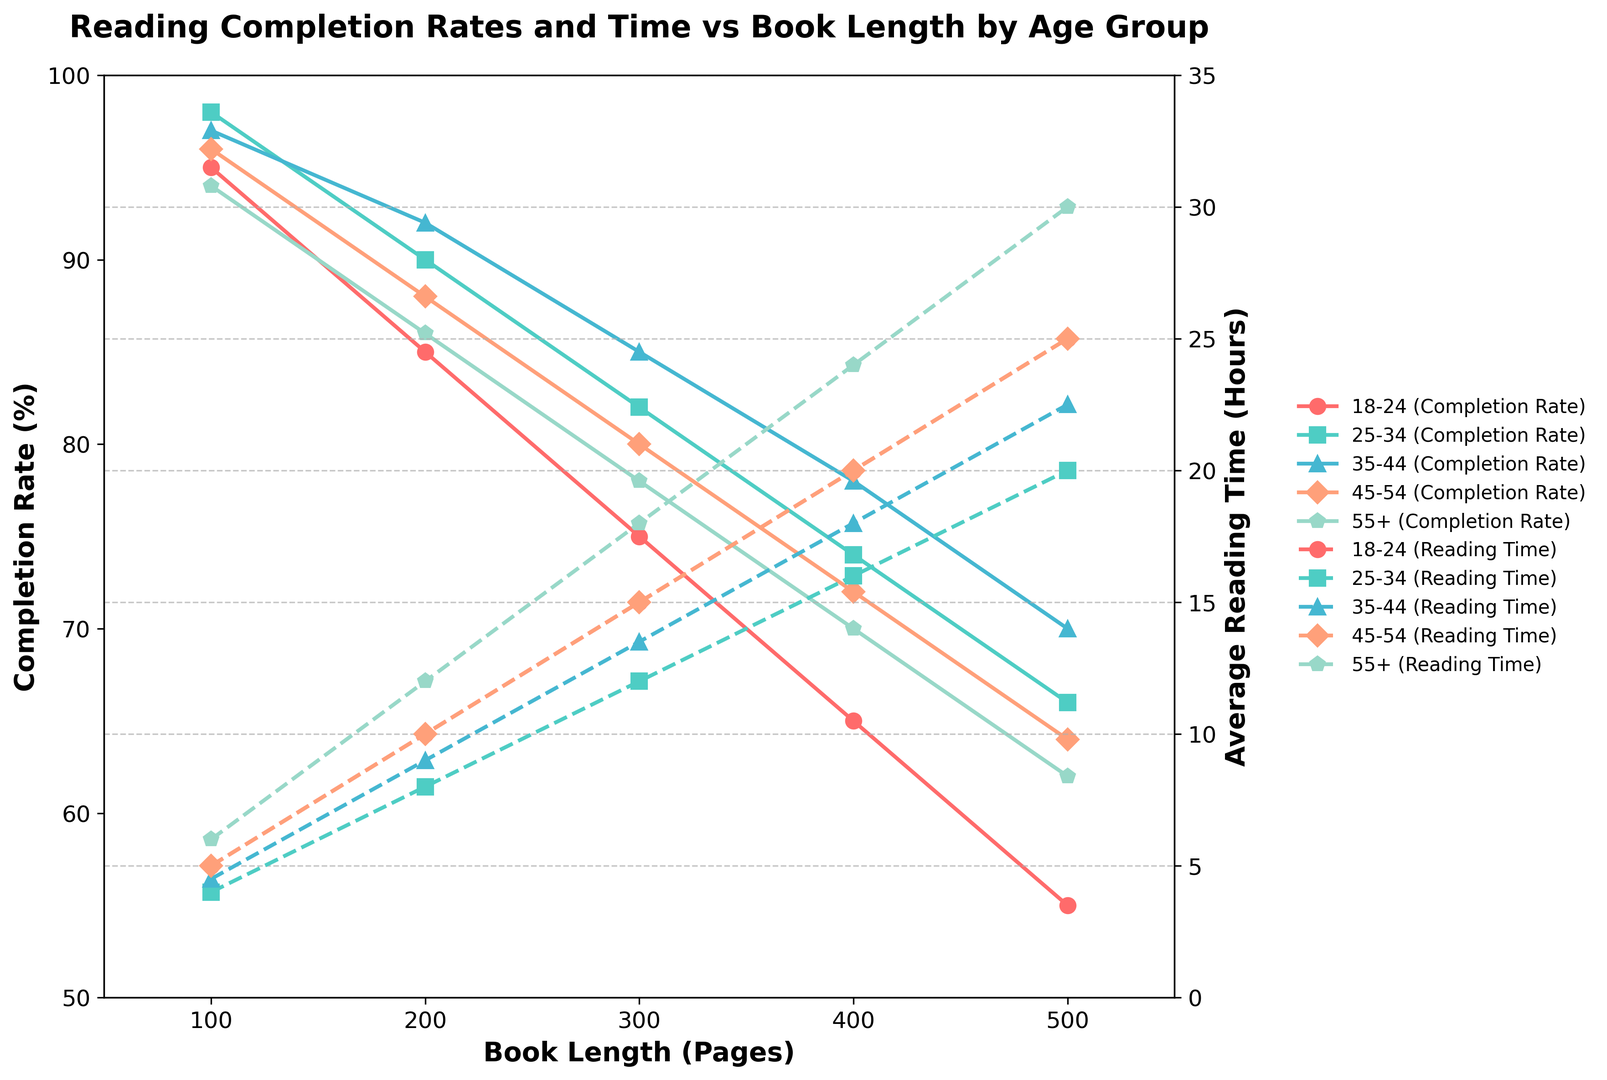Which age group has the highest reading completion rate for a book with 100 pages? The plot shows each age group’s completion rates for different book lengths with distinct markers. For the 100-page book, the 25-34 age group has the highest reading completion rate.
Answer: 25-34 How does the completion rate for the 45-54 age group compare with the 55+ age group for a 300-page book? The plot indicates that for a 300-page book, the completion rates are 80% for the 45-54 age group and 78% for the 55+ age group. The 45-54 age group has a slightly higher completion rate.
Answer: 45-54 has a higher rate What is the difference in average reading time between the 18-24 and 55+ age groups for a 400-page book? Looking at the dashed lines on the plot, the average reading time for the 18-24 age group is 20 hours and for the 55+ age group is 24 hours for a 400-page book. The difference is 24 - 20 = 4 hours.
Answer: 4 hours Which age group has the smallest change in reading completion rate between a 200-page and a 500-page book? By comparing the completion rates for 200-page and 500-page books across all age groups, the 55+ age group shows the least change: from 86% to 62%, a change of 24%. Other groups show larger changes.
Answer: 55+ For the 18-24 age group, what is the average reading time per hour for a 500-page book? The average reading time is given as 25 hours for a 500-page book. The completion rate is 55%. The time per hour is calculated as 500 pages / 25 hours = 20 pages per hour.
Answer: 20 pages per hour Which age group has the fastest average reading time for a 300-page book? By examining the dashed lines for a 300-page book, the fastest average reading time is held by the 25-34 age group, with 12 hours.
Answer: 25-34 How does the completion rate for the 35-44 age group change from a 100-page book to a 400-page book? For the 35-44 age group, the completion rate decreases from 97% for a 100-page book to 78% for a 400-page book. This is a decrease of 97 - 78 = 19%.
Answer: Decreases by 19% What is the average completion rate for the 18-24 age group for books up to 300 pages? For the 18-24 age group, the completion rates for 100, 200, and 300 pages are 95%, 85%, and 75%, respectively. The average is (95 + 85 + 75) / 3 = 85%.
Answer: 85% What color represents the 45-54 age group on the plot, and how can you tell? The 45-54 age group is represented by an orange color. Each age group is assigned a distinct color, and by examining the legend, the orange corresponds to the 45-54 age group.
Answer: Orange By how many percentage points does the completion rate drop for the 25-34 age group from a 100-page to a 500-page book? For the 25-34 age group, the completion rate drops from 98% for a 100-page book to 66% for a 500-page book. The drop is 98 - 66 = 32 percentage points.
Answer: 32 points 